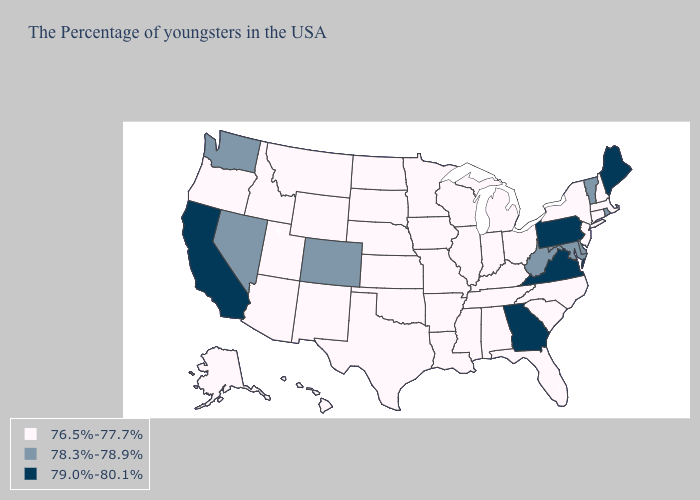What is the value of Kentucky?
Concise answer only. 76.5%-77.7%. What is the lowest value in states that border North Dakota?
Write a very short answer. 76.5%-77.7%. Among the states that border New Hampshire , which have the highest value?
Keep it brief. Maine. Name the states that have a value in the range 76.5%-77.7%?
Write a very short answer. Massachusetts, New Hampshire, Connecticut, New York, New Jersey, North Carolina, South Carolina, Ohio, Florida, Michigan, Kentucky, Indiana, Alabama, Tennessee, Wisconsin, Illinois, Mississippi, Louisiana, Missouri, Arkansas, Minnesota, Iowa, Kansas, Nebraska, Oklahoma, Texas, South Dakota, North Dakota, Wyoming, New Mexico, Utah, Montana, Arizona, Idaho, Oregon, Alaska, Hawaii. Name the states that have a value in the range 78.3%-78.9%?
Quick response, please. Rhode Island, Vermont, Delaware, Maryland, West Virginia, Colorado, Nevada, Washington. Name the states that have a value in the range 79.0%-80.1%?
Write a very short answer. Maine, Pennsylvania, Virginia, Georgia, California. Does Kentucky have a lower value than Massachusetts?
Answer briefly. No. Among the states that border Louisiana , which have the highest value?
Concise answer only. Mississippi, Arkansas, Texas. What is the value of Delaware?
Quick response, please. 78.3%-78.9%. Among the states that border Nebraska , does Kansas have the highest value?
Short answer required. No. Among the states that border Oregon , which have the highest value?
Concise answer only. California. Name the states that have a value in the range 78.3%-78.9%?
Be succinct. Rhode Island, Vermont, Delaware, Maryland, West Virginia, Colorado, Nevada, Washington. Among the states that border Delaware , which have the highest value?
Quick response, please. Pennsylvania. Name the states that have a value in the range 78.3%-78.9%?
Concise answer only. Rhode Island, Vermont, Delaware, Maryland, West Virginia, Colorado, Nevada, Washington. Does the first symbol in the legend represent the smallest category?
Concise answer only. Yes. 